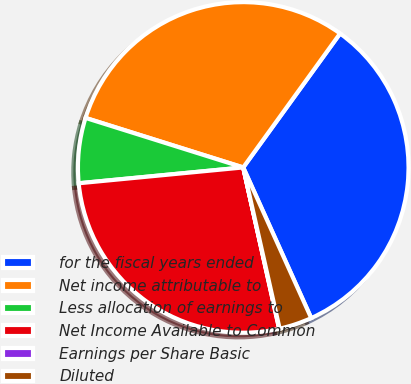Convert chart. <chart><loc_0><loc_0><loc_500><loc_500><pie_chart><fcel>for the fiscal years ended<fcel>Net income attributable to<fcel>Less allocation of earnings to<fcel>Net Income Available to Common<fcel>Earnings per Share Basic<fcel>Diluted<nl><fcel>33.29%<fcel>30.12%<fcel>6.37%<fcel>26.96%<fcel>0.05%<fcel>3.21%<nl></chart> 